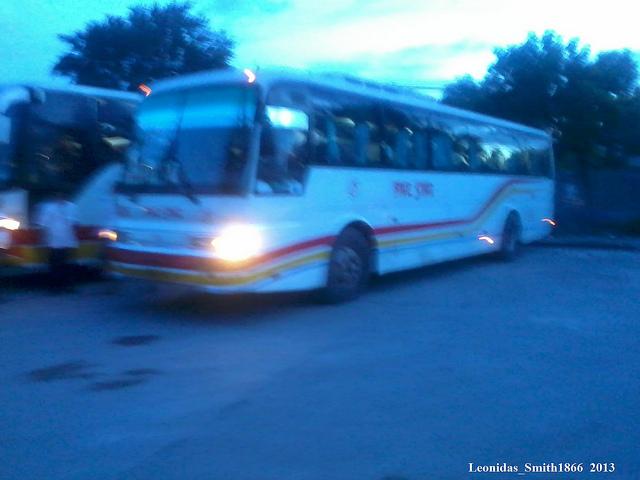How many buses are there?
Short answer required. 2. Is this a double decker bus?
Give a very brief answer. No. Are the buses in focus?
Quick response, please. No. The 3 stripes on the bus are yellow, white, and what?
Answer briefly. Red. 